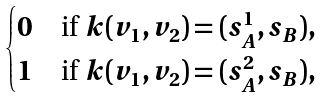Convert formula to latex. <formula><loc_0><loc_0><loc_500><loc_500>\begin{cases} 0 & \text {if } k ( v _ { 1 } , v _ { 2 } ) = ( s _ { A } ^ { 1 } , s _ { B } ) , \\ 1 & \text {if } k ( v _ { 1 } , v _ { 2 } ) = ( s _ { A } ^ { 2 } , s _ { B } ) , \end{cases}</formula> 